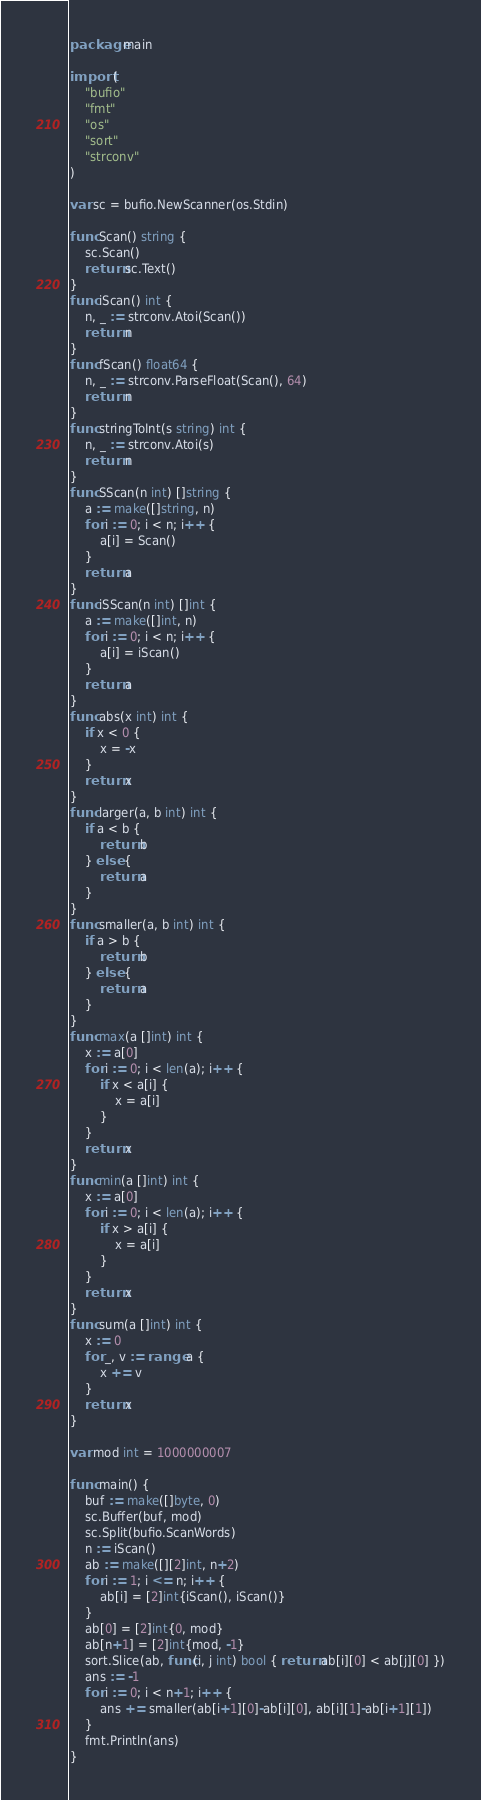Convert code to text. <code><loc_0><loc_0><loc_500><loc_500><_Go_>package main

import (
	"bufio"
	"fmt"
	"os"
	"sort"
	"strconv"
)

var sc = bufio.NewScanner(os.Stdin)

func Scan() string {
	sc.Scan()
	return sc.Text()
}
func iScan() int {
	n, _ := strconv.Atoi(Scan())
	return n
}
func fScan() float64 {
	n, _ := strconv.ParseFloat(Scan(), 64)
	return n
}
func stringToInt(s string) int {
	n, _ := strconv.Atoi(s)
	return n
}
func SScan(n int) []string {
	a := make([]string, n)
	for i := 0; i < n; i++ {
		a[i] = Scan()
	}
	return a
}
func iSScan(n int) []int {
	a := make([]int, n)
	for i := 0; i < n; i++ {
		a[i] = iScan()
	}
	return a
}
func abs(x int) int {
	if x < 0 {
		x = -x
	}
	return x
}
func larger(a, b int) int {
	if a < b {
		return b
	} else {
		return a
	}
}
func smaller(a, b int) int {
	if a > b {
		return b
	} else {
		return a
	}
}
func max(a []int) int {
	x := a[0]
	for i := 0; i < len(a); i++ {
		if x < a[i] {
			x = a[i]
		}
	}
	return x
}
func min(a []int) int {
	x := a[0]
	for i := 0; i < len(a); i++ {
		if x > a[i] {
			x = a[i]
		}
	}
	return x
}
func sum(a []int) int {
	x := 0
	for _, v := range a {
		x += v
	}
	return x
}

var mod int = 1000000007

func main() {
	buf := make([]byte, 0)
	sc.Buffer(buf, mod)
	sc.Split(bufio.ScanWords)
	n := iScan()
	ab := make([][2]int, n+2)
	for i := 1; i <= n; i++ {
		ab[i] = [2]int{iScan(), iScan()}
	}
	ab[0] = [2]int{0, mod}
	ab[n+1] = [2]int{mod, -1}
	sort.Slice(ab, func(i, j int) bool { return ab[i][0] < ab[j][0] })
	ans := -1
	for i := 0; i < n+1; i++ {
		ans += smaller(ab[i+1][0]-ab[i][0], ab[i][1]-ab[i+1][1])
	}
	fmt.Println(ans)
}
</code> 